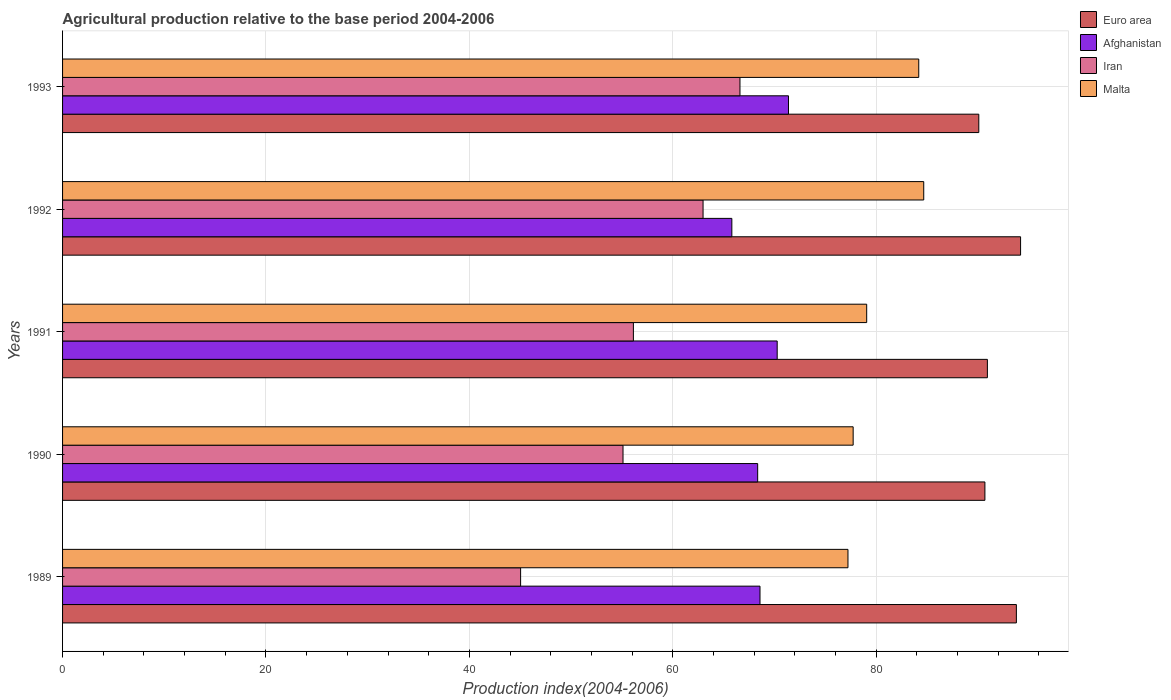What is the label of the 5th group of bars from the top?
Your answer should be compact. 1989. In how many cases, is the number of bars for a given year not equal to the number of legend labels?
Provide a succinct answer. 0. What is the agricultural production index in Iran in 1992?
Keep it short and to the point. 62.98. Across all years, what is the maximum agricultural production index in Malta?
Give a very brief answer. 84.68. Across all years, what is the minimum agricultural production index in Iran?
Make the answer very short. 45.04. In which year was the agricultural production index in Iran maximum?
Make the answer very short. 1993. In which year was the agricultural production index in Afghanistan minimum?
Provide a short and direct response. 1992. What is the total agricultural production index in Afghanistan in the graph?
Provide a short and direct response. 344.39. What is the difference between the agricultural production index in Iran in 1990 and that in 1992?
Your answer should be very brief. -7.87. What is the difference between the agricultural production index in Iran in 1993 and the agricultural production index in Euro area in 1989?
Your response must be concise. -27.18. What is the average agricultural production index in Iran per year?
Keep it short and to the point. 57.17. In the year 1990, what is the difference between the agricultural production index in Afghanistan and agricultural production index in Euro area?
Offer a very short reply. -22.34. What is the ratio of the agricultural production index in Iran in 1992 to that in 1993?
Provide a succinct answer. 0.95. What is the difference between the highest and the second highest agricultural production index in Malta?
Make the answer very short. 0.49. What is the difference between the highest and the lowest agricultural production index in Afghanistan?
Your answer should be very brief. 5.57. In how many years, is the agricultural production index in Iran greater than the average agricultural production index in Iran taken over all years?
Make the answer very short. 2. Is the sum of the agricultural production index in Iran in 1989 and 1990 greater than the maximum agricultural production index in Euro area across all years?
Provide a succinct answer. Yes. Is it the case that in every year, the sum of the agricultural production index in Euro area and agricultural production index in Iran is greater than the sum of agricultural production index in Malta and agricultural production index in Afghanistan?
Make the answer very short. No. What does the 2nd bar from the bottom in 1991 represents?
Offer a very short reply. Afghanistan. How many bars are there?
Offer a very short reply. 20. What is the difference between two consecutive major ticks on the X-axis?
Provide a succinct answer. 20. Does the graph contain grids?
Provide a short and direct response. Yes. What is the title of the graph?
Provide a short and direct response. Agricultural production relative to the base period 2004-2006. What is the label or title of the X-axis?
Keep it short and to the point. Production index(2004-2006). What is the label or title of the Y-axis?
Your response must be concise. Years. What is the Production index(2004-2006) of Euro area in 1989?
Provide a short and direct response. 93.79. What is the Production index(2004-2006) in Afghanistan in 1989?
Give a very brief answer. 68.58. What is the Production index(2004-2006) of Iran in 1989?
Ensure brevity in your answer.  45.04. What is the Production index(2004-2006) of Malta in 1989?
Your answer should be very brief. 77.23. What is the Production index(2004-2006) in Euro area in 1990?
Make the answer very short. 90.69. What is the Production index(2004-2006) of Afghanistan in 1990?
Your answer should be very brief. 68.35. What is the Production index(2004-2006) of Iran in 1990?
Provide a short and direct response. 55.11. What is the Production index(2004-2006) in Malta in 1990?
Provide a short and direct response. 77.74. What is the Production index(2004-2006) in Euro area in 1991?
Give a very brief answer. 90.94. What is the Production index(2004-2006) of Afghanistan in 1991?
Offer a very short reply. 70.27. What is the Production index(2004-2006) of Iran in 1991?
Your answer should be very brief. 56.13. What is the Production index(2004-2006) in Malta in 1991?
Ensure brevity in your answer.  79.07. What is the Production index(2004-2006) in Euro area in 1992?
Keep it short and to the point. 94.2. What is the Production index(2004-2006) in Afghanistan in 1992?
Your response must be concise. 65.81. What is the Production index(2004-2006) of Iran in 1992?
Offer a very short reply. 62.98. What is the Production index(2004-2006) of Malta in 1992?
Ensure brevity in your answer.  84.68. What is the Production index(2004-2006) of Euro area in 1993?
Your answer should be very brief. 90.09. What is the Production index(2004-2006) in Afghanistan in 1993?
Offer a very short reply. 71.38. What is the Production index(2004-2006) in Iran in 1993?
Your answer should be compact. 66.61. What is the Production index(2004-2006) in Malta in 1993?
Offer a very short reply. 84.19. Across all years, what is the maximum Production index(2004-2006) in Euro area?
Your answer should be very brief. 94.2. Across all years, what is the maximum Production index(2004-2006) of Afghanistan?
Give a very brief answer. 71.38. Across all years, what is the maximum Production index(2004-2006) of Iran?
Provide a short and direct response. 66.61. Across all years, what is the maximum Production index(2004-2006) in Malta?
Give a very brief answer. 84.68. Across all years, what is the minimum Production index(2004-2006) of Euro area?
Make the answer very short. 90.09. Across all years, what is the minimum Production index(2004-2006) in Afghanistan?
Your answer should be compact. 65.81. Across all years, what is the minimum Production index(2004-2006) of Iran?
Your answer should be very brief. 45.04. Across all years, what is the minimum Production index(2004-2006) of Malta?
Your answer should be compact. 77.23. What is the total Production index(2004-2006) in Euro area in the graph?
Give a very brief answer. 459.72. What is the total Production index(2004-2006) in Afghanistan in the graph?
Your response must be concise. 344.39. What is the total Production index(2004-2006) of Iran in the graph?
Provide a short and direct response. 285.87. What is the total Production index(2004-2006) of Malta in the graph?
Keep it short and to the point. 402.91. What is the difference between the Production index(2004-2006) of Euro area in 1989 and that in 1990?
Provide a short and direct response. 3.09. What is the difference between the Production index(2004-2006) of Afghanistan in 1989 and that in 1990?
Make the answer very short. 0.23. What is the difference between the Production index(2004-2006) in Iran in 1989 and that in 1990?
Offer a terse response. -10.07. What is the difference between the Production index(2004-2006) of Malta in 1989 and that in 1990?
Your answer should be compact. -0.51. What is the difference between the Production index(2004-2006) of Euro area in 1989 and that in 1991?
Provide a short and direct response. 2.85. What is the difference between the Production index(2004-2006) of Afghanistan in 1989 and that in 1991?
Your response must be concise. -1.69. What is the difference between the Production index(2004-2006) of Iran in 1989 and that in 1991?
Make the answer very short. -11.09. What is the difference between the Production index(2004-2006) of Malta in 1989 and that in 1991?
Your response must be concise. -1.84. What is the difference between the Production index(2004-2006) in Euro area in 1989 and that in 1992?
Give a very brief answer. -0.41. What is the difference between the Production index(2004-2006) of Afghanistan in 1989 and that in 1992?
Keep it short and to the point. 2.77. What is the difference between the Production index(2004-2006) in Iran in 1989 and that in 1992?
Provide a succinct answer. -17.94. What is the difference between the Production index(2004-2006) in Malta in 1989 and that in 1992?
Make the answer very short. -7.45. What is the difference between the Production index(2004-2006) in Euro area in 1989 and that in 1993?
Ensure brevity in your answer.  3.7. What is the difference between the Production index(2004-2006) of Iran in 1989 and that in 1993?
Your answer should be compact. -21.57. What is the difference between the Production index(2004-2006) in Malta in 1989 and that in 1993?
Offer a very short reply. -6.96. What is the difference between the Production index(2004-2006) of Euro area in 1990 and that in 1991?
Your answer should be compact. -0.24. What is the difference between the Production index(2004-2006) in Afghanistan in 1990 and that in 1991?
Provide a succinct answer. -1.92. What is the difference between the Production index(2004-2006) in Iran in 1990 and that in 1991?
Offer a very short reply. -1.02. What is the difference between the Production index(2004-2006) of Malta in 1990 and that in 1991?
Your answer should be very brief. -1.33. What is the difference between the Production index(2004-2006) of Euro area in 1990 and that in 1992?
Your response must be concise. -3.51. What is the difference between the Production index(2004-2006) of Afghanistan in 1990 and that in 1992?
Your response must be concise. 2.54. What is the difference between the Production index(2004-2006) of Iran in 1990 and that in 1992?
Provide a succinct answer. -7.87. What is the difference between the Production index(2004-2006) in Malta in 1990 and that in 1992?
Your answer should be compact. -6.94. What is the difference between the Production index(2004-2006) of Euro area in 1990 and that in 1993?
Your answer should be very brief. 0.6. What is the difference between the Production index(2004-2006) of Afghanistan in 1990 and that in 1993?
Offer a terse response. -3.03. What is the difference between the Production index(2004-2006) of Malta in 1990 and that in 1993?
Ensure brevity in your answer.  -6.45. What is the difference between the Production index(2004-2006) of Euro area in 1991 and that in 1992?
Provide a short and direct response. -3.26. What is the difference between the Production index(2004-2006) of Afghanistan in 1991 and that in 1992?
Your response must be concise. 4.46. What is the difference between the Production index(2004-2006) of Iran in 1991 and that in 1992?
Offer a terse response. -6.85. What is the difference between the Production index(2004-2006) of Malta in 1991 and that in 1992?
Keep it short and to the point. -5.61. What is the difference between the Production index(2004-2006) in Euro area in 1991 and that in 1993?
Make the answer very short. 0.85. What is the difference between the Production index(2004-2006) in Afghanistan in 1991 and that in 1993?
Give a very brief answer. -1.11. What is the difference between the Production index(2004-2006) of Iran in 1991 and that in 1993?
Your answer should be very brief. -10.48. What is the difference between the Production index(2004-2006) of Malta in 1991 and that in 1993?
Make the answer very short. -5.12. What is the difference between the Production index(2004-2006) in Euro area in 1992 and that in 1993?
Offer a terse response. 4.11. What is the difference between the Production index(2004-2006) of Afghanistan in 1992 and that in 1993?
Give a very brief answer. -5.57. What is the difference between the Production index(2004-2006) in Iran in 1992 and that in 1993?
Your answer should be very brief. -3.63. What is the difference between the Production index(2004-2006) of Malta in 1992 and that in 1993?
Give a very brief answer. 0.49. What is the difference between the Production index(2004-2006) of Euro area in 1989 and the Production index(2004-2006) of Afghanistan in 1990?
Keep it short and to the point. 25.44. What is the difference between the Production index(2004-2006) of Euro area in 1989 and the Production index(2004-2006) of Iran in 1990?
Keep it short and to the point. 38.68. What is the difference between the Production index(2004-2006) of Euro area in 1989 and the Production index(2004-2006) of Malta in 1990?
Ensure brevity in your answer.  16.05. What is the difference between the Production index(2004-2006) of Afghanistan in 1989 and the Production index(2004-2006) of Iran in 1990?
Your answer should be compact. 13.47. What is the difference between the Production index(2004-2006) in Afghanistan in 1989 and the Production index(2004-2006) in Malta in 1990?
Offer a terse response. -9.16. What is the difference between the Production index(2004-2006) of Iran in 1989 and the Production index(2004-2006) of Malta in 1990?
Offer a terse response. -32.7. What is the difference between the Production index(2004-2006) of Euro area in 1989 and the Production index(2004-2006) of Afghanistan in 1991?
Offer a very short reply. 23.52. What is the difference between the Production index(2004-2006) of Euro area in 1989 and the Production index(2004-2006) of Iran in 1991?
Make the answer very short. 37.66. What is the difference between the Production index(2004-2006) of Euro area in 1989 and the Production index(2004-2006) of Malta in 1991?
Make the answer very short. 14.72. What is the difference between the Production index(2004-2006) of Afghanistan in 1989 and the Production index(2004-2006) of Iran in 1991?
Provide a succinct answer. 12.45. What is the difference between the Production index(2004-2006) in Afghanistan in 1989 and the Production index(2004-2006) in Malta in 1991?
Give a very brief answer. -10.49. What is the difference between the Production index(2004-2006) of Iran in 1989 and the Production index(2004-2006) of Malta in 1991?
Give a very brief answer. -34.03. What is the difference between the Production index(2004-2006) of Euro area in 1989 and the Production index(2004-2006) of Afghanistan in 1992?
Make the answer very short. 27.98. What is the difference between the Production index(2004-2006) in Euro area in 1989 and the Production index(2004-2006) in Iran in 1992?
Your answer should be compact. 30.81. What is the difference between the Production index(2004-2006) of Euro area in 1989 and the Production index(2004-2006) of Malta in 1992?
Ensure brevity in your answer.  9.11. What is the difference between the Production index(2004-2006) in Afghanistan in 1989 and the Production index(2004-2006) in Iran in 1992?
Give a very brief answer. 5.6. What is the difference between the Production index(2004-2006) in Afghanistan in 1989 and the Production index(2004-2006) in Malta in 1992?
Offer a very short reply. -16.1. What is the difference between the Production index(2004-2006) in Iran in 1989 and the Production index(2004-2006) in Malta in 1992?
Provide a short and direct response. -39.64. What is the difference between the Production index(2004-2006) in Euro area in 1989 and the Production index(2004-2006) in Afghanistan in 1993?
Your answer should be very brief. 22.41. What is the difference between the Production index(2004-2006) of Euro area in 1989 and the Production index(2004-2006) of Iran in 1993?
Provide a short and direct response. 27.18. What is the difference between the Production index(2004-2006) of Euro area in 1989 and the Production index(2004-2006) of Malta in 1993?
Your response must be concise. 9.6. What is the difference between the Production index(2004-2006) in Afghanistan in 1989 and the Production index(2004-2006) in Iran in 1993?
Provide a succinct answer. 1.97. What is the difference between the Production index(2004-2006) of Afghanistan in 1989 and the Production index(2004-2006) of Malta in 1993?
Keep it short and to the point. -15.61. What is the difference between the Production index(2004-2006) in Iran in 1989 and the Production index(2004-2006) in Malta in 1993?
Give a very brief answer. -39.15. What is the difference between the Production index(2004-2006) in Euro area in 1990 and the Production index(2004-2006) in Afghanistan in 1991?
Provide a short and direct response. 20.42. What is the difference between the Production index(2004-2006) in Euro area in 1990 and the Production index(2004-2006) in Iran in 1991?
Provide a succinct answer. 34.56. What is the difference between the Production index(2004-2006) in Euro area in 1990 and the Production index(2004-2006) in Malta in 1991?
Offer a very short reply. 11.62. What is the difference between the Production index(2004-2006) in Afghanistan in 1990 and the Production index(2004-2006) in Iran in 1991?
Your answer should be compact. 12.22. What is the difference between the Production index(2004-2006) in Afghanistan in 1990 and the Production index(2004-2006) in Malta in 1991?
Your response must be concise. -10.72. What is the difference between the Production index(2004-2006) in Iran in 1990 and the Production index(2004-2006) in Malta in 1991?
Provide a short and direct response. -23.96. What is the difference between the Production index(2004-2006) of Euro area in 1990 and the Production index(2004-2006) of Afghanistan in 1992?
Provide a short and direct response. 24.88. What is the difference between the Production index(2004-2006) of Euro area in 1990 and the Production index(2004-2006) of Iran in 1992?
Offer a terse response. 27.71. What is the difference between the Production index(2004-2006) in Euro area in 1990 and the Production index(2004-2006) in Malta in 1992?
Ensure brevity in your answer.  6.01. What is the difference between the Production index(2004-2006) of Afghanistan in 1990 and the Production index(2004-2006) of Iran in 1992?
Provide a succinct answer. 5.37. What is the difference between the Production index(2004-2006) of Afghanistan in 1990 and the Production index(2004-2006) of Malta in 1992?
Your answer should be very brief. -16.33. What is the difference between the Production index(2004-2006) of Iran in 1990 and the Production index(2004-2006) of Malta in 1992?
Keep it short and to the point. -29.57. What is the difference between the Production index(2004-2006) in Euro area in 1990 and the Production index(2004-2006) in Afghanistan in 1993?
Ensure brevity in your answer.  19.31. What is the difference between the Production index(2004-2006) of Euro area in 1990 and the Production index(2004-2006) of Iran in 1993?
Your response must be concise. 24.08. What is the difference between the Production index(2004-2006) of Euro area in 1990 and the Production index(2004-2006) of Malta in 1993?
Provide a succinct answer. 6.5. What is the difference between the Production index(2004-2006) of Afghanistan in 1990 and the Production index(2004-2006) of Iran in 1993?
Offer a very short reply. 1.74. What is the difference between the Production index(2004-2006) in Afghanistan in 1990 and the Production index(2004-2006) in Malta in 1993?
Provide a short and direct response. -15.84. What is the difference between the Production index(2004-2006) of Iran in 1990 and the Production index(2004-2006) of Malta in 1993?
Offer a very short reply. -29.08. What is the difference between the Production index(2004-2006) of Euro area in 1991 and the Production index(2004-2006) of Afghanistan in 1992?
Provide a succinct answer. 25.13. What is the difference between the Production index(2004-2006) of Euro area in 1991 and the Production index(2004-2006) of Iran in 1992?
Make the answer very short. 27.96. What is the difference between the Production index(2004-2006) in Euro area in 1991 and the Production index(2004-2006) in Malta in 1992?
Keep it short and to the point. 6.26. What is the difference between the Production index(2004-2006) in Afghanistan in 1991 and the Production index(2004-2006) in Iran in 1992?
Provide a short and direct response. 7.29. What is the difference between the Production index(2004-2006) of Afghanistan in 1991 and the Production index(2004-2006) of Malta in 1992?
Make the answer very short. -14.41. What is the difference between the Production index(2004-2006) in Iran in 1991 and the Production index(2004-2006) in Malta in 1992?
Offer a terse response. -28.55. What is the difference between the Production index(2004-2006) of Euro area in 1991 and the Production index(2004-2006) of Afghanistan in 1993?
Offer a terse response. 19.56. What is the difference between the Production index(2004-2006) of Euro area in 1991 and the Production index(2004-2006) of Iran in 1993?
Ensure brevity in your answer.  24.33. What is the difference between the Production index(2004-2006) in Euro area in 1991 and the Production index(2004-2006) in Malta in 1993?
Offer a terse response. 6.75. What is the difference between the Production index(2004-2006) in Afghanistan in 1991 and the Production index(2004-2006) in Iran in 1993?
Your response must be concise. 3.66. What is the difference between the Production index(2004-2006) of Afghanistan in 1991 and the Production index(2004-2006) of Malta in 1993?
Offer a terse response. -13.92. What is the difference between the Production index(2004-2006) of Iran in 1991 and the Production index(2004-2006) of Malta in 1993?
Provide a succinct answer. -28.06. What is the difference between the Production index(2004-2006) in Euro area in 1992 and the Production index(2004-2006) in Afghanistan in 1993?
Your answer should be very brief. 22.82. What is the difference between the Production index(2004-2006) of Euro area in 1992 and the Production index(2004-2006) of Iran in 1993?
Your response must be concise. 27.59. What is the difference between the Production index(2004-2006) of Euro area in 1992 and the Production index(2004-2006) of Malta in 1993?
Offer a terse response. 10.01. What is the difference between the Production index(2004-2006) in Afghanistan in 1992 and the Production index(2004-2006) in Iran in 1993?
Make the answer very short. -0.8. What is the difference between the Production index(2004-2006) of Afghanistan in 1992 and the Production index(2004-2006) of Malta in 1993?
Your answer should be very brief. -18.38. What is the difference between the Production index(2004-2006) of Iran in 1992 and the Production index(2004-2006) of Malta in 1993?
Offer a terse response. -21.21. What is the average Production index(2004-2006) of Euro area per year?
Make the answer very short. 91.94. What is the average Production index(2004-2006) of Afghanistan per year?
Offer a terse response. 68.88. What is the average Production index(2004-2006) in Iran per year?
Provide a succinct answer. 57.17. What is the average Production index(2004-2006) of Malta per year?
Keep it short and to the point. 80.58. In the year 1989, what is the difference between the Production index(2004-2006) of Euro area and Production index(2004-2006) of Afghanistan?
Offer a very short reply. 25.21. In the year 1989, what is the difference between the Production index(2004-2006) of Euro area and Production index(2004-2006) of Iran?
Your answer should be very brief. 48.75. In the year 1989, what is the difference between the Production index(2004-2006) of Euro area and Production index(2004-2006) of Malta?
Provide a short and direct response. 16.56. In the year 1989, what is the difference between the Production index(2004-2006) of Afghanistan and Production index(2004-2006) of Iran?
Keep it short and to the point. 23.54. In the year 1989, what is the difference between the Production index(2004-2006) of Afghanistan and Production index(2004-2006) of Malta?
Keep it short and to the point. -8.65. In the year 1989, what is the difference between the Production index(2004-2006) of Iran and Production index(2004-2006) of Malta?
Your answer should be compact. -32.19. In the year 1990, what is the difference between the Production index(2004-2006) of Euro area and Production index(2004-2006) of Afghanistan?
Provide a succinct answer. 22.34. In the year 1990, what is the difference between the Production index(2004-2006) in Euro area and Production index(2004-2006) in Iran?
Offer a very short reply. 35.58. In the year 1990, what is the difference between the Production index(2004-2006) in Euro area and Production index(2004-2006) in Malta?
Your answer should be very brief. 12.95. In the year 1990, what is the difference between the Production index(2004-2006) in Afghanistan and Production index(2004-2006) in Iran?
Your response must be concise. 13.24. In the year 1990, what is the difference between the Production index(2004-2006) of Afghanistan and Production index(2004-2006) of Malta?
Provide a succinct answer. -9.39. In the year 1990, what is the difference between the Production index(2004-2006) in Iran and Production index(2004-2006) in Malta?
Your answer should be compact. -22.63. In the year 1991, what is the difference between the Production index(2004-2006) of Euro area and Production index(2004-2006) of Afghanistan?
Your answer should be compact. 20.67. In the year 1991, what is the difference between the Production index(2004-2006) in Euro area and Production index(2004-2006) in Iran?
Offer a very short reply. 34.81. In the year 1991, what is the difference between the Production index(2004-2006) in Euro area and Production index(2004-2006) in Malta?
Keep it short and to the point. 11.87. In the year 1991, what is the difference between the Production index(2004-2006) of Afghanistan and Production index(2004-2006) of Iran?
Provide a short and direct response. 14.14. In the year 1991, what is the difference between the Production index(2004-2006) of Afghanistan and Production index(2004-2006) of Malta?
Offer a very short reply. -8.8. In the year 1991, what is the difference between the Production index(2004-2006) of Iran and Production index(2004-2006) of Malta?
Offer a terse response. -22.94. In the year 1992, what is the difference between the Production index(2004-2006) of Euro area and Production index(2004-2006) of Afghanistan?
Provide a succinct answer. 28.39. In the year 1992, what is the difference between the Production index(2004-2006) in Euro area and Production index(2004-2006) in Iran?
Provide a succinct answer. 31.22. In the year 1992, what is the difference between the Production index(2004-2006) of Euro area and Production index(2004-2006) of Malta?
Your answer should be very brief. 9.52. In the year 1992, what is the difference between the Production index(2004-2006) of Afghanistan and Production index(2004-2006) of Iran?
Your answer should be compact. 2.83. In the year 1992, what is the difference between the Production index(2004-2006) in Afghanistan and Production index(2004-2006) in Malta?
Provide a short and direct response. -18.87. In the year 1992, what is the difference between the Production index(2004-2006) in Iran and Production index(2004-2006) in Malta?
Your response must be concise. -21.7. In the year 1993, what is the difference between the Production index(2004-2006) in Euro area and Production index(2004-2006) in Afghanistan?
Your answer should be very brief. 18.71. In the year 1993, what is the difference between the Production index(2004-2006) in Euro area and Production index(2004-2006) in Iran?
Offer a very short reply. 23.48. In the year 1993, what is the difference between the Production index(2004-2006) of Euro area and Production index(2004-2006) of Malta?
Offer a terse response. 5.9. In the year 1993, what is the difference between the Production index(2004-2006) of Afghanistan and Production index(2004-2006) of Iran?
Ensure brevity in your answer.  4.77. In the year 1993, what is the difference between the Production index(2004-2006) in Afghanistan and Production index(2004-2006) in Malta?
Your answer should be very brief. -12.81. In the year 1993, what is the difference between the Production index(2004-2006) of Iran and Production index(2004-2006) of Malta?
Your answer should be very brief. -17.58. What is the ratio of the Production index(2004-2006) of Euro area in 1989 to that in 1990?
Provide a short and direct response. 1.03. What is the ratio of the Production index(2004-2006) in Iran in 1989 to that in 1990?
Your response must be concise. 0.82. What is the ratio of the Production index(2004-2006) in Malta in 1989 to that in 1990?
Offer a very short reply. 0.99. What is the ratio of the Production index(2004-2006) in Euro area in 1989 to that in 1991?
Offer a terse response. 1.03. What is the ratio of the Production index(2004-2006) of Afghanistan in 1989 to that in 1991?
Your answer should be very brief. 0.98. What is the ratio of the Production index(2004-2006) of Iran in 1989 to that in 1991?
Your answer should be compact. 0.8. What is the ratio of the Production index(2004-2006) in Malta in 1989 to that in 1991?
Keep it short and to the point. 0.98. What is the ratio of the Production index(2004-2006) in Euro area in 1989 to that in 1992?
Your response must be concise. 1. What is the ratio of the Production index(2004-2006) in Afghanistan in 1989 to that in 1992?
Keep it short and to the point. 1.04. What is the ratio of the Production index(2004-2006) in Iran in 1989 to that in 1992?
Ensure brevity in your answer.  0.72. What is the ratio of the Production index(2004-2006) of Malta in 1989 to that in 1992?
Keep it short and to the point. 0.91. What is the ratio of the Production index(2004-2006) in Euro area in 1989 to that in 1993?
Provide a short and direct response. 1.04. What is the ratio of the Production index(2004-2006) of Afghanistan in 1989 to that in 1993?
Provide a succinct answer. 0.96. What is the ratio of the Production index(2004-2006) in Iran in 1989 to that in 1993?
Keep it short and to the point. 0.68. What is the ratio of the Production index(2004-2006) in Malta in 1989 to that in 1993?
Ensure brevity in your answer.  0.92. What is the ratio of the Production index(2004-2006) of Afghanistan in 1990 to that in 1991?
Your answer should be compact. 0.97. What is the ratio of the Production index(2004-2006) of Iran in 1990 to that in 1991?
Keep it short and to the point. 0.98. What is the ratio of the Production index(2004-2006) in Malta in 1990 to that in 1991?
Your answer should be very brief. 0.98. What is the ratio of the Production index(2004-2006) in Euro area in 1990 to that in 1992?
Offer a terse response. 0.96. What is the ratio of the Production index(2004-2006) in Afghanistan in 1990 to that in 1992?
Make the answer very short. 1.04. What is the ratio of the Production index(2004-2006) in Malta in 1990 to that in 1992?
Your answer should be compact. 0.92. What is the ratio of the Production index(2004-2006) in Afghanistan in 1990 to that in 1993?
Ensure brevity in your answer.  0.96. What is the ratio of the Production index(2004-2006) in Iran in 1990 to that in 1993?
Your response must be concise. 0.83. What is the ratio of the Production index(2004-2006) of Malta in 1990 to that in 1993?
Provide a short and direct response. 0.92. What is the ratio of the Production index(2004-2006) of Euro area in 1991 to that in 1992?
Keep it short and to the point. 0.97. What is the ratio of the Production index(2004-2006) in Afghanistan in 1991 to that in 1992?
Your answer should be compact. 1.07. What is the ratio of the Production index(2004-2006) in Iran in 1991 to that in 1992?
Your answer should be very brief. 0.89. What is the ratio of the Production index(2004-2006) of Malta in 1991 to that in 1992?
Keep it short and to the point. 0.93. What is the ratio of the Production index(2004-2006) in Euro area in 1991 to that in 1993?
Give a very brief answer. 1.01. What is the ratio of the Production index(2004-2006) in Afghanistan in 1991 to that in 1993?
Provide a succinct answer. 0.98. What is the ratio of the Production index(2004-2006) in Iran in 1991 to that in 1993?
Keep it short and to the point. 0.84. What is the ratio of the Production index(2004-2006) in Malta in 1991 to that in 1993?
Make the answer very short. 0.94. What is the ratio of the Production index(2004-2006) of Euro area in 1992 to that in 1993?
Offer a terse response. 1.05. What is the ratio of the Production index(2004-2006) in Afghanistan in 1992 to that in 1993?
Your answer should be compact. 0.92. What is the ratio of the Production index(2004-2006) in Iran in 1992 to that in 1993?
Give a very brief answer. 0.95. What is the ratio of the Production index(2004-2006) of Malta in 1992 to that in 1993?
Offer a very short reply. 1.01. What is the difference between the highest and the second highest Production index(2004-2006) in Euro area?
Provide a succinct answer. 0.41. What is the difference between the highest and the second highest Production index(2004-2006) in Afghanistan?
Make the answer very short. 1.11. What is the difference between the highest and the second highest Production index(2004-2006) of Iran?
Ensure brevity in your answer.  3.63. What is the difference between the highest and the second highest Production index(2004-2006) in Malta?
Provide a succinct answer. 0.49. What is the difference between the highest and the lowest Production index(2004-2006) of Euro area?
Provide a short and direct response. 4.11. What is the difference between the highest and the lowest Production index(2004-2006) of Afghanistan?
Make the answer very short. 5.57. What is the difference between the highest and the lowest Production index(2004-2006) of Iran?
Provide a short and direct response. 21.57. What is the difference between the highest and the lowest Production index(2004-2006) of Malta?
Your response must be concise. 7.45. 